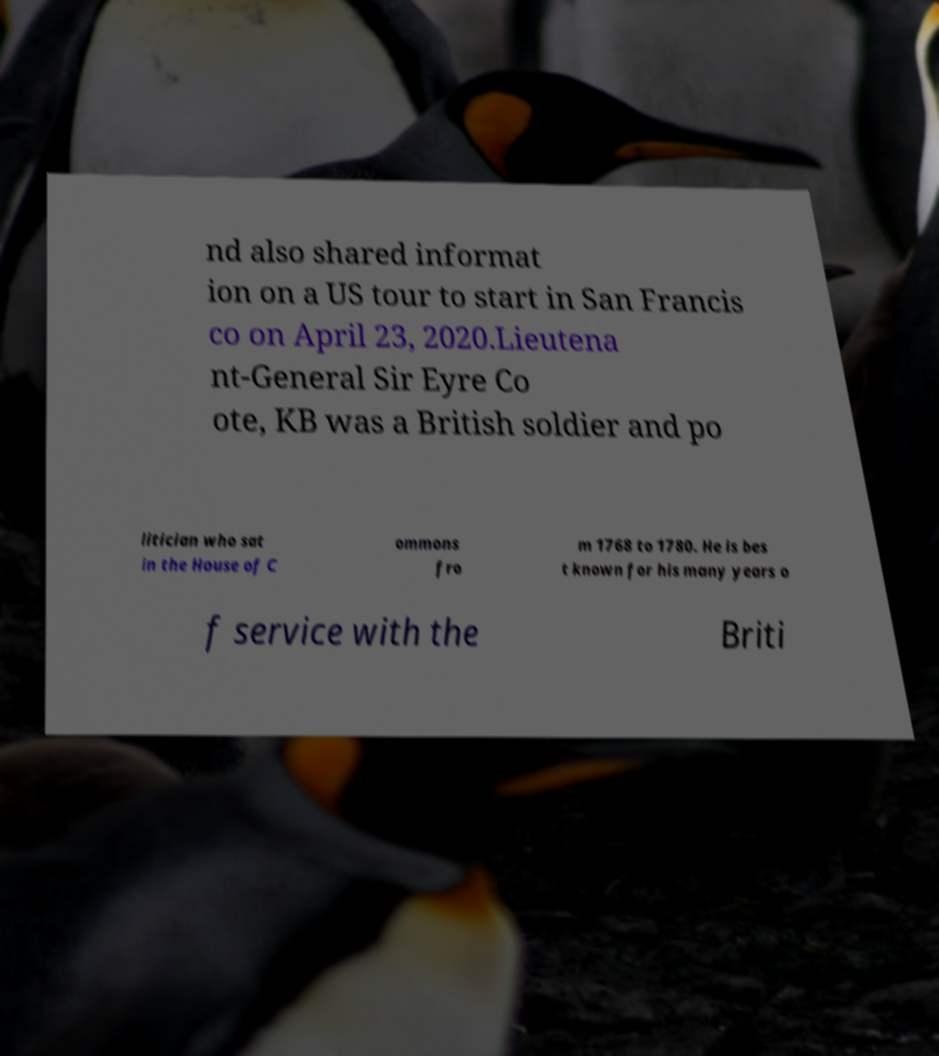Could you assist in decoding the text presented in this image and type it out clearly? nd also shared informat ion on a US tour to start in San Francis co on April 23, 2020.Lieutena nt-General Sir Eyre Co ote, KB was a British soldier and po litician who sat in the House of C ommons fro m 1768 to 1780. He is bes t known for his many years o f service with the Briti 